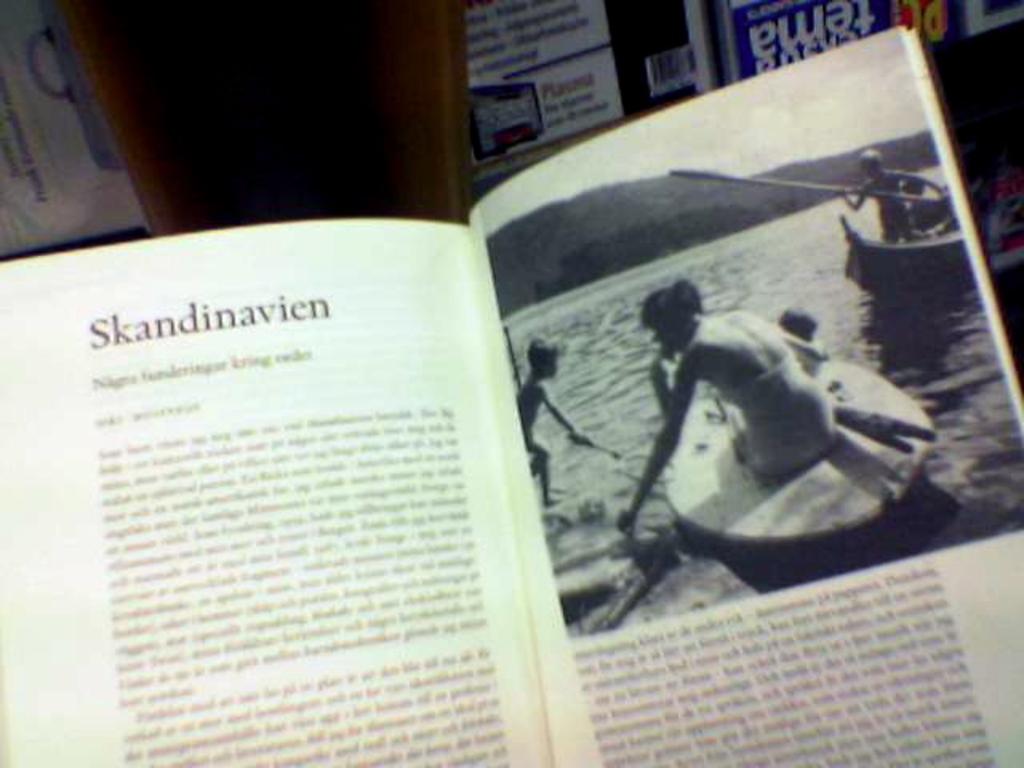What does the top of the page say?
Provide a short and direct response. Skandinavien. Is this a book about skandanavia?
Provide a short and direct response. Yes. 